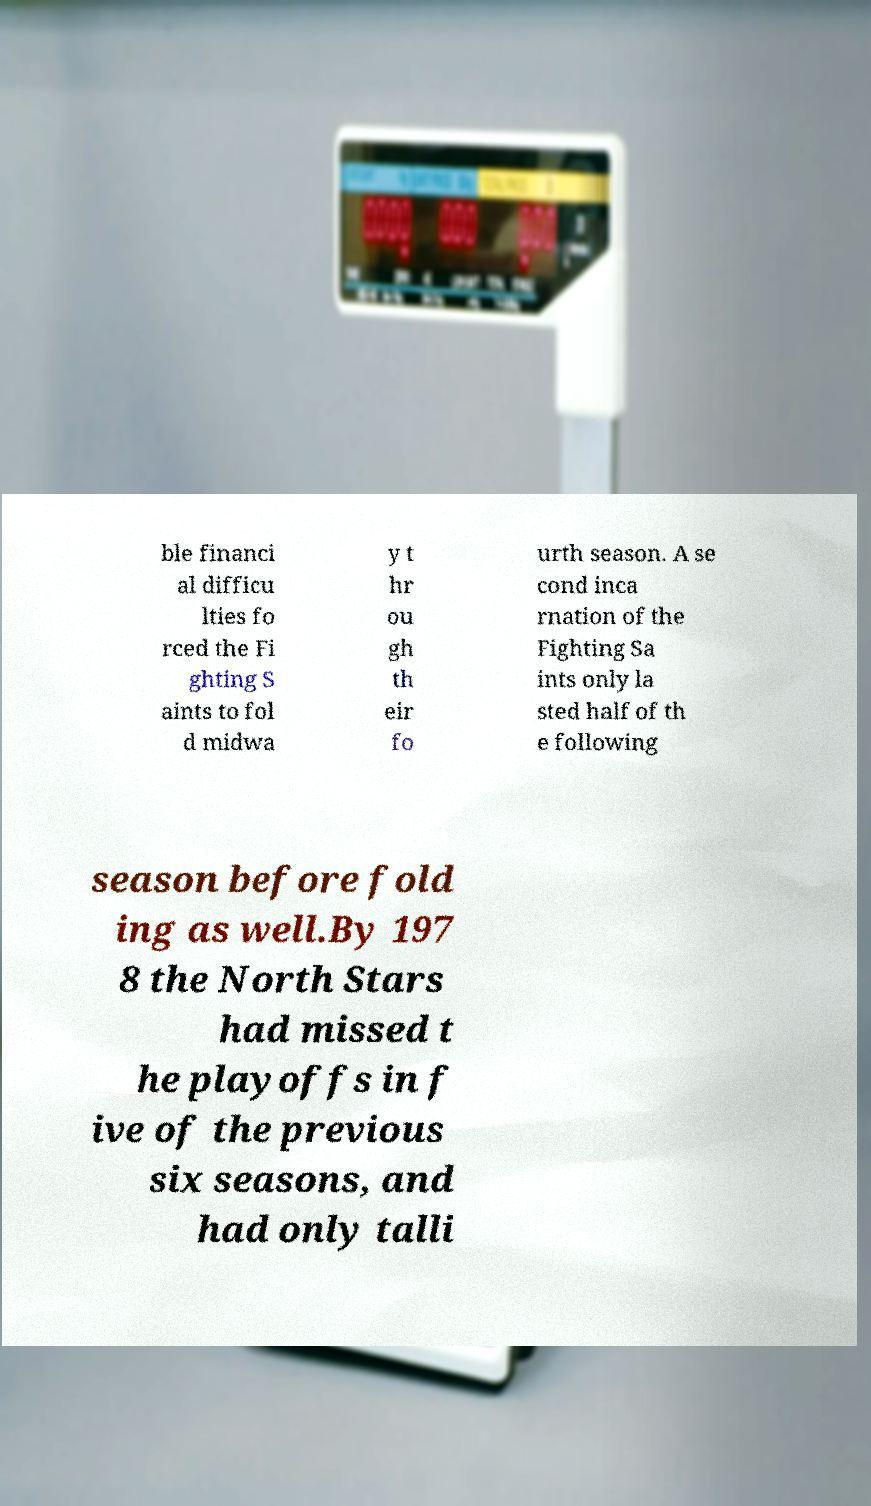I need the written content from this picture converted into text. Can you do that? ble financi al difficu lties fo rced the Fi ghting S aints to fol d midwa y t hr ou gh th eir fo urth season. A se cond inca rnation of the Fighting Sa ints only la sted half of th e following season before fold ing as well.By 197 8 the North Stars had missed t he playoffs in f ive of the previous six seasons, and had only talli 